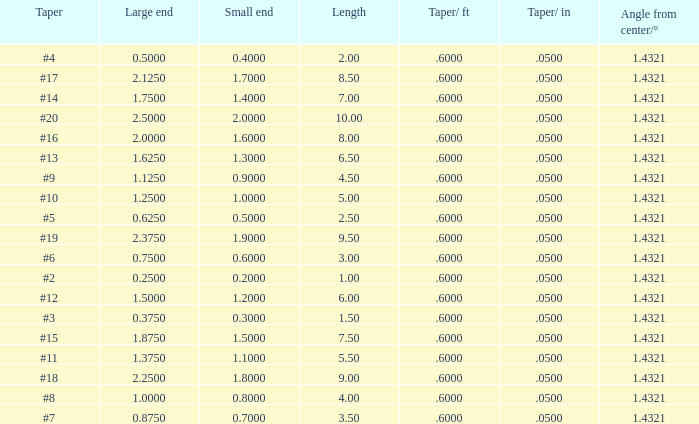Which Taper/in that has a Small end larger than 0.7000000000000001, and a Taper of #19, and a Large end larger than 2.375? None. 